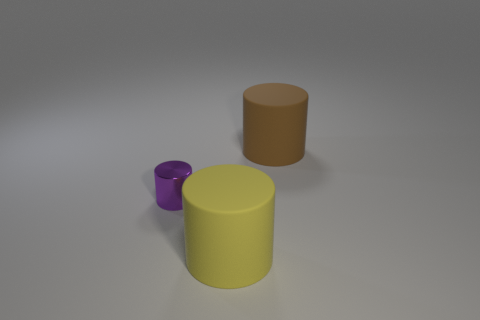Subtract all large matte cylinders. How many cylinders are left? 1 Subtract all blue cylinders. Subtract all blue cubes. How many cylinders are left? 3 Add 1 shiny objects. How many objects exist? 4 Subtract 0 cyan balls. How many objects are left? 3 Subtract all blue balls. Subtract all large cylinders. How many objects are left? 1 Add 2 big yellow cylinders. How many big yellow cylinders are left? 3 Add 1 big rubber cylinders. How many big rubber cylinders exist? 3 